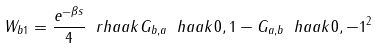<formula> <loc_0><loc_0><loc_500><loc_500>W _ { b 1 } = \frac { e ^ { - \beta s } } { 4 } \ r h a a k { G _ { b , a } \ h a a k { 0 , 1 } - G _ { a , b } \ h a a k { 0 , - 1 } } ^ { 2 }</formula> 